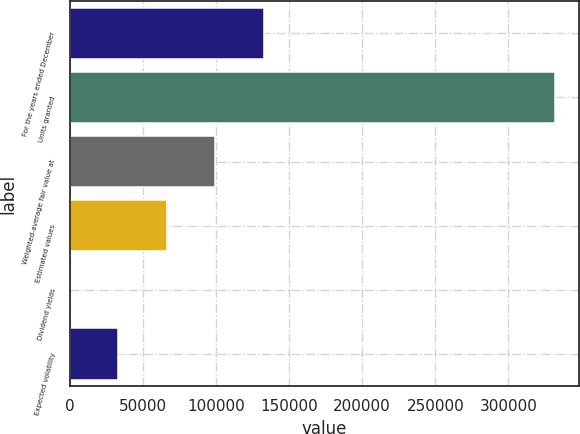Convert chart. <chart><loc_0><loc_0><loc_500><loc_500><bar_chart><fcel>For the years ended December<fcel>Units granted<fcel>Weighted-average fair value at<fcel>Estimated values<fcel>Dividend yields<fcel>Expected volatility<nl><fcel>132716<fcel>331788<fcel>99537.7<fcel>66359<fcel>1.8<fcel>33180.4<nl></chart> 